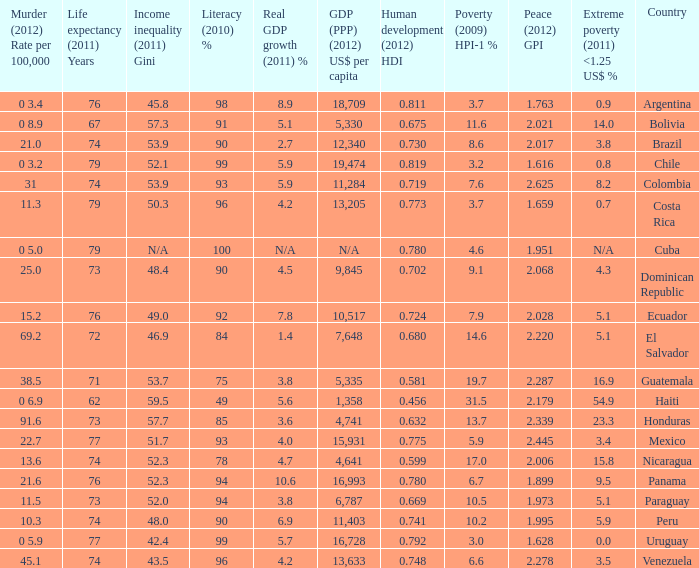What is the total poverty (2009) HPI-1 % when the extreme poverty (2011) <1.25 US$ % of 16.9, and the human development (2012) HDI is less than 0.581? None. 